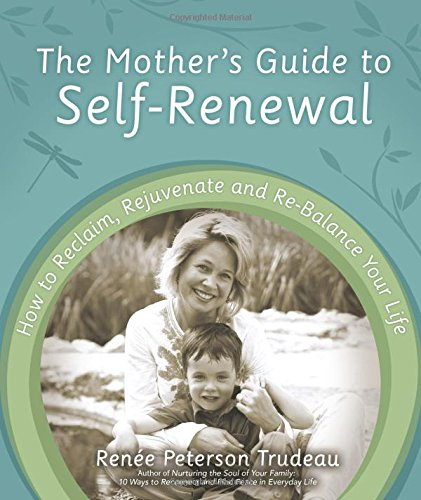Is this book related to Science & Math? No, this book is not related to Science & Math. It primarily focuses on themes of personal renewal and self-care specifically designed with mothers in mind. 